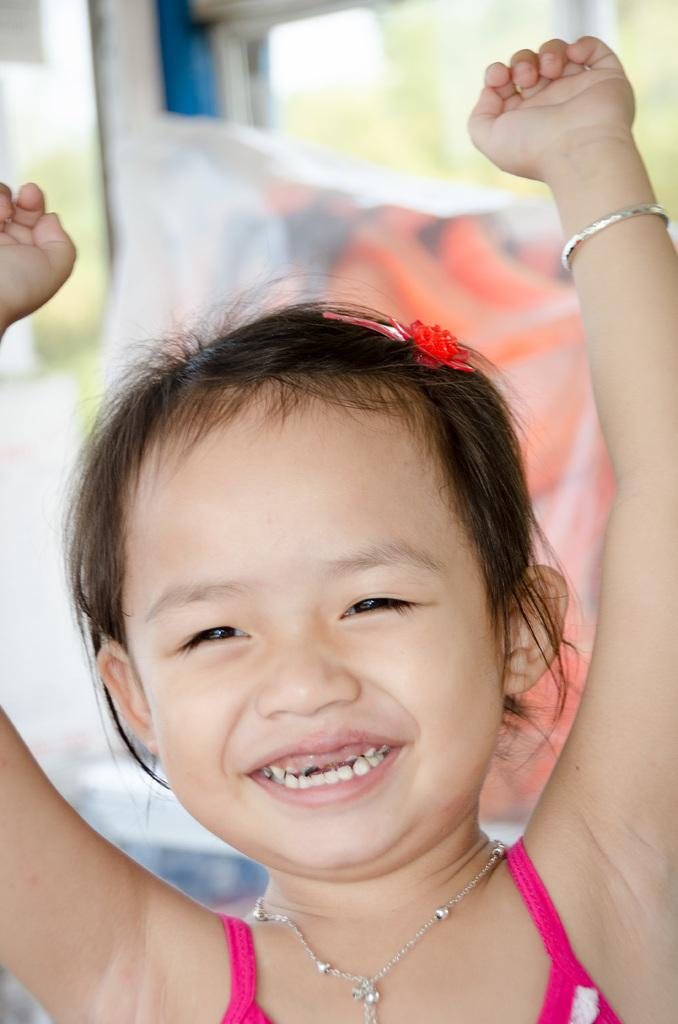What is the main subject of the image? There is a girl standing in the image. What is located behind the girl? There is a pillow behind the girl. Can you describe the background of the image? The background of the image is blurred. What type of feather can be seen in the girl's hair in the image? There is no feather visible in the girl's hair in the image. Can you tell me where the nearest zoo is in relation to the girl in the image? The image does not provide any information about the location of a zoo, so it cannot be determined from the image. 